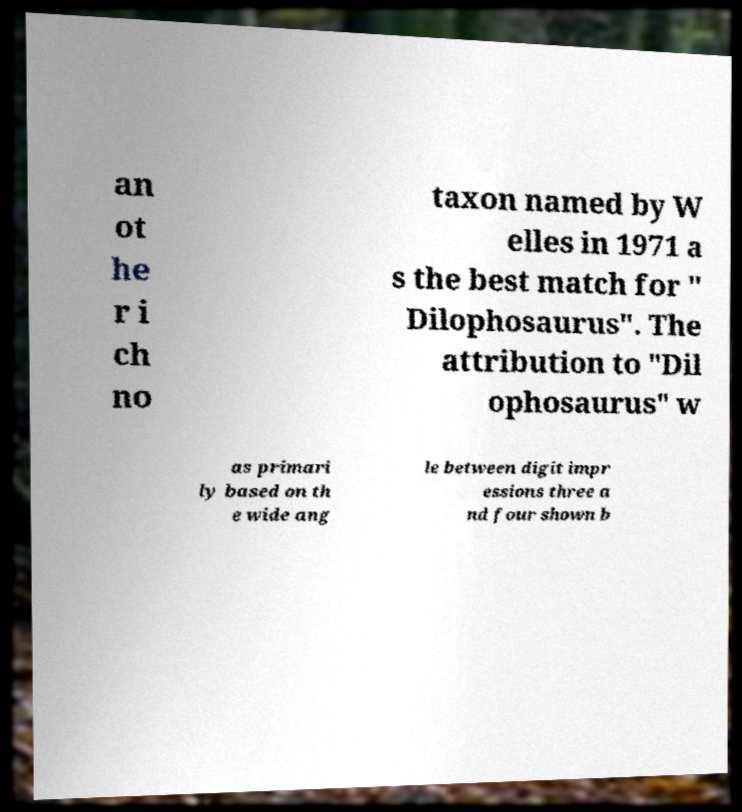There's text embedded in this image that I need extracted. Can you transcribe it verbatim? an ot he r i ch no taxon named by W elles in 1971 a s the best match for " Dilophosaurus". The attribution to "Dil ophosaurus" w as primari ly based on th e wide ang le between digit impr essions three a nd four shown b 